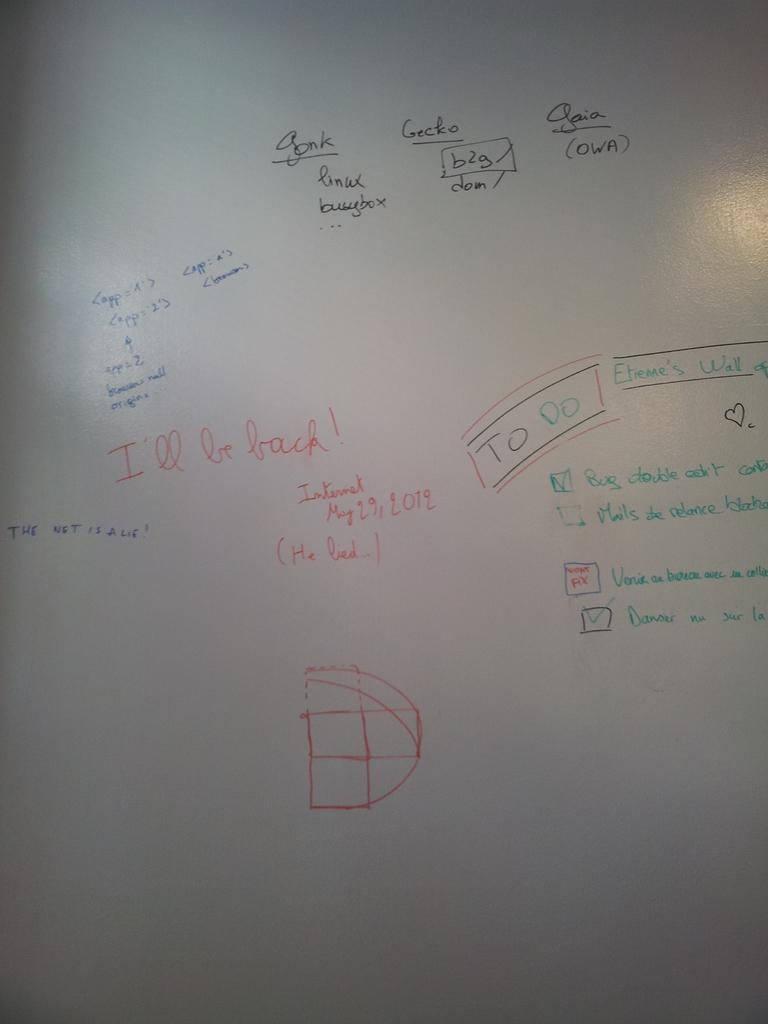<image>
Describe the image concisely. A white board with various writings including I'll be back. 